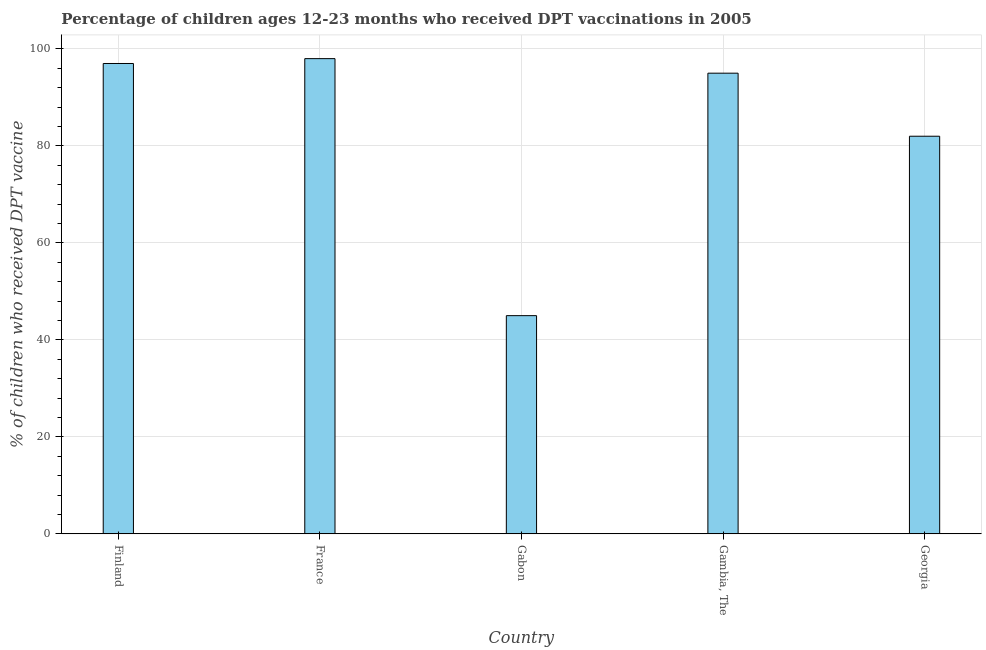Does the graph contain any zero values?
Offer a terse response. No. What is the title of the graph?
Offer a terse response. Percentage of children ages 12-23 months who received DPT vaccinations in 2005. What is the label or title of the X-axis?
Make the answer very short. Country. What is the label or title of the Y-axis?
Provide a succinct answer. % of children who received DPT vaccine. What is the percentage of children who received dpt vaccine in Gambia, The?
Your answer should be compact. 95. Across all countries, what is the minimum percentage of children who received dpt vaccine?
Make the answer very short. 45. In which country was the percentage of children who received dpt vaccine minimum?
Give a very brief answer. Gabon. What is the sum of the percentage of children who received dpt vaccine?
Your response must be concise. 417. What is the difference between the percentage of children who received dpt vaccine in France and Gabon?
Provide a succinct answer. 53. What is the average percentage of children who received dpt vaccine per country?
Keep it short and to the point. 83.4. What is the ratio of the percentage of children who received dpt vaccine in Finland to that in Gabon?
Offer a terse response. 2.16. Is the percentage of children who received dpt vaccine in Gabon less than that in Gambia, The?
Ensure brevity in your answer.  Yes. Is the difference between the percentage of children who received dpt vaccine in Finland and Georgia greater than the difference between any two countries?
Provide a succinct answer. No. Is the sum of the percentage of children who received dpt vaccine in Gabon and Gambia, The greater than the maximum percentage of children who received dpt vaccine across all countries?
Your answer should be very brief. Yes. What is the difference between the highest and the lowest percentage of children who received dpt vaccine?
Ensure brevity in your answer.  53. In how many countries, is the percentage of children who received dpt vaccine greater than the average percentage of children who received dpt vaccine taken over all countries?
Make the answer very short. 3. What is the % of children who received DPT vaccine in Finland?
Your answer should be very brief. 97. What is the % of children who received DPT vaccine in France?
Ensure brevity in your answer.  98. What is the % of children who received DPT vaccine of Gabon?
Your response must be concise. 45. What is the difference between the % of children who received DPT vaccine in Finland and France?
Your response must be concise. -1. What is the difference between the % of children who received DPT vaccine in Finland and Gabon?
Offer a terse response. 52. What is the difference between the % of children who received DPT vaccine in Finland and Georgia?
Your answer should be very brief. 15. What is the difference between the % of children who received DPT vaccine in France and Gambia, The?
Give a very brief answer. 3. What is the difference between the % of children who received DPT vaccine in Gabon and Georgia?
Make the answer very short. -37. What is the difference between the % of children who received DPT vaccine in Gambia, The and Georgia?
Offer a terse response. 13. What is the ratio of the % of children who received DPT vaccine in Finland to that in Gabon?
Your answer should be very brief. 2.16. What is the ratio of the % of children who received DPT vaccine in Finland to that in Gambia, The?
Your answer should be very brief. 1.02. What is the ratio of the % of children who received DPT vaccine in Finland to that in Georgia?
Your answer should be compact. 1.18. What is the ratio of the % of children who received DPT vaccine in France to that in Gabon?
Give a very brief answer. 2.18. What is the ratio of the % of children who received DPT vaccine in France to that in Gambia, The?
Provide a short and direct response. 1.03. What is the ratio of the % of children who received DPT vaccine in France to that in Georgia?
Your answer should be compact. 1.2. What is the ratio of the % of children who received DPT vaccine in Gabon to that in Gambia, The?
Keep it short and to the point. 0.47. What is the ratio of the % of children who received DPT vaccine in Gabon to that in Georgia?
Ensure brevity in your answer.  0.55. What is the ratio of the % of children who received DPT vaccine in Gambia, The to that in Georgia?
Keep it short and to the point. 1.16. 